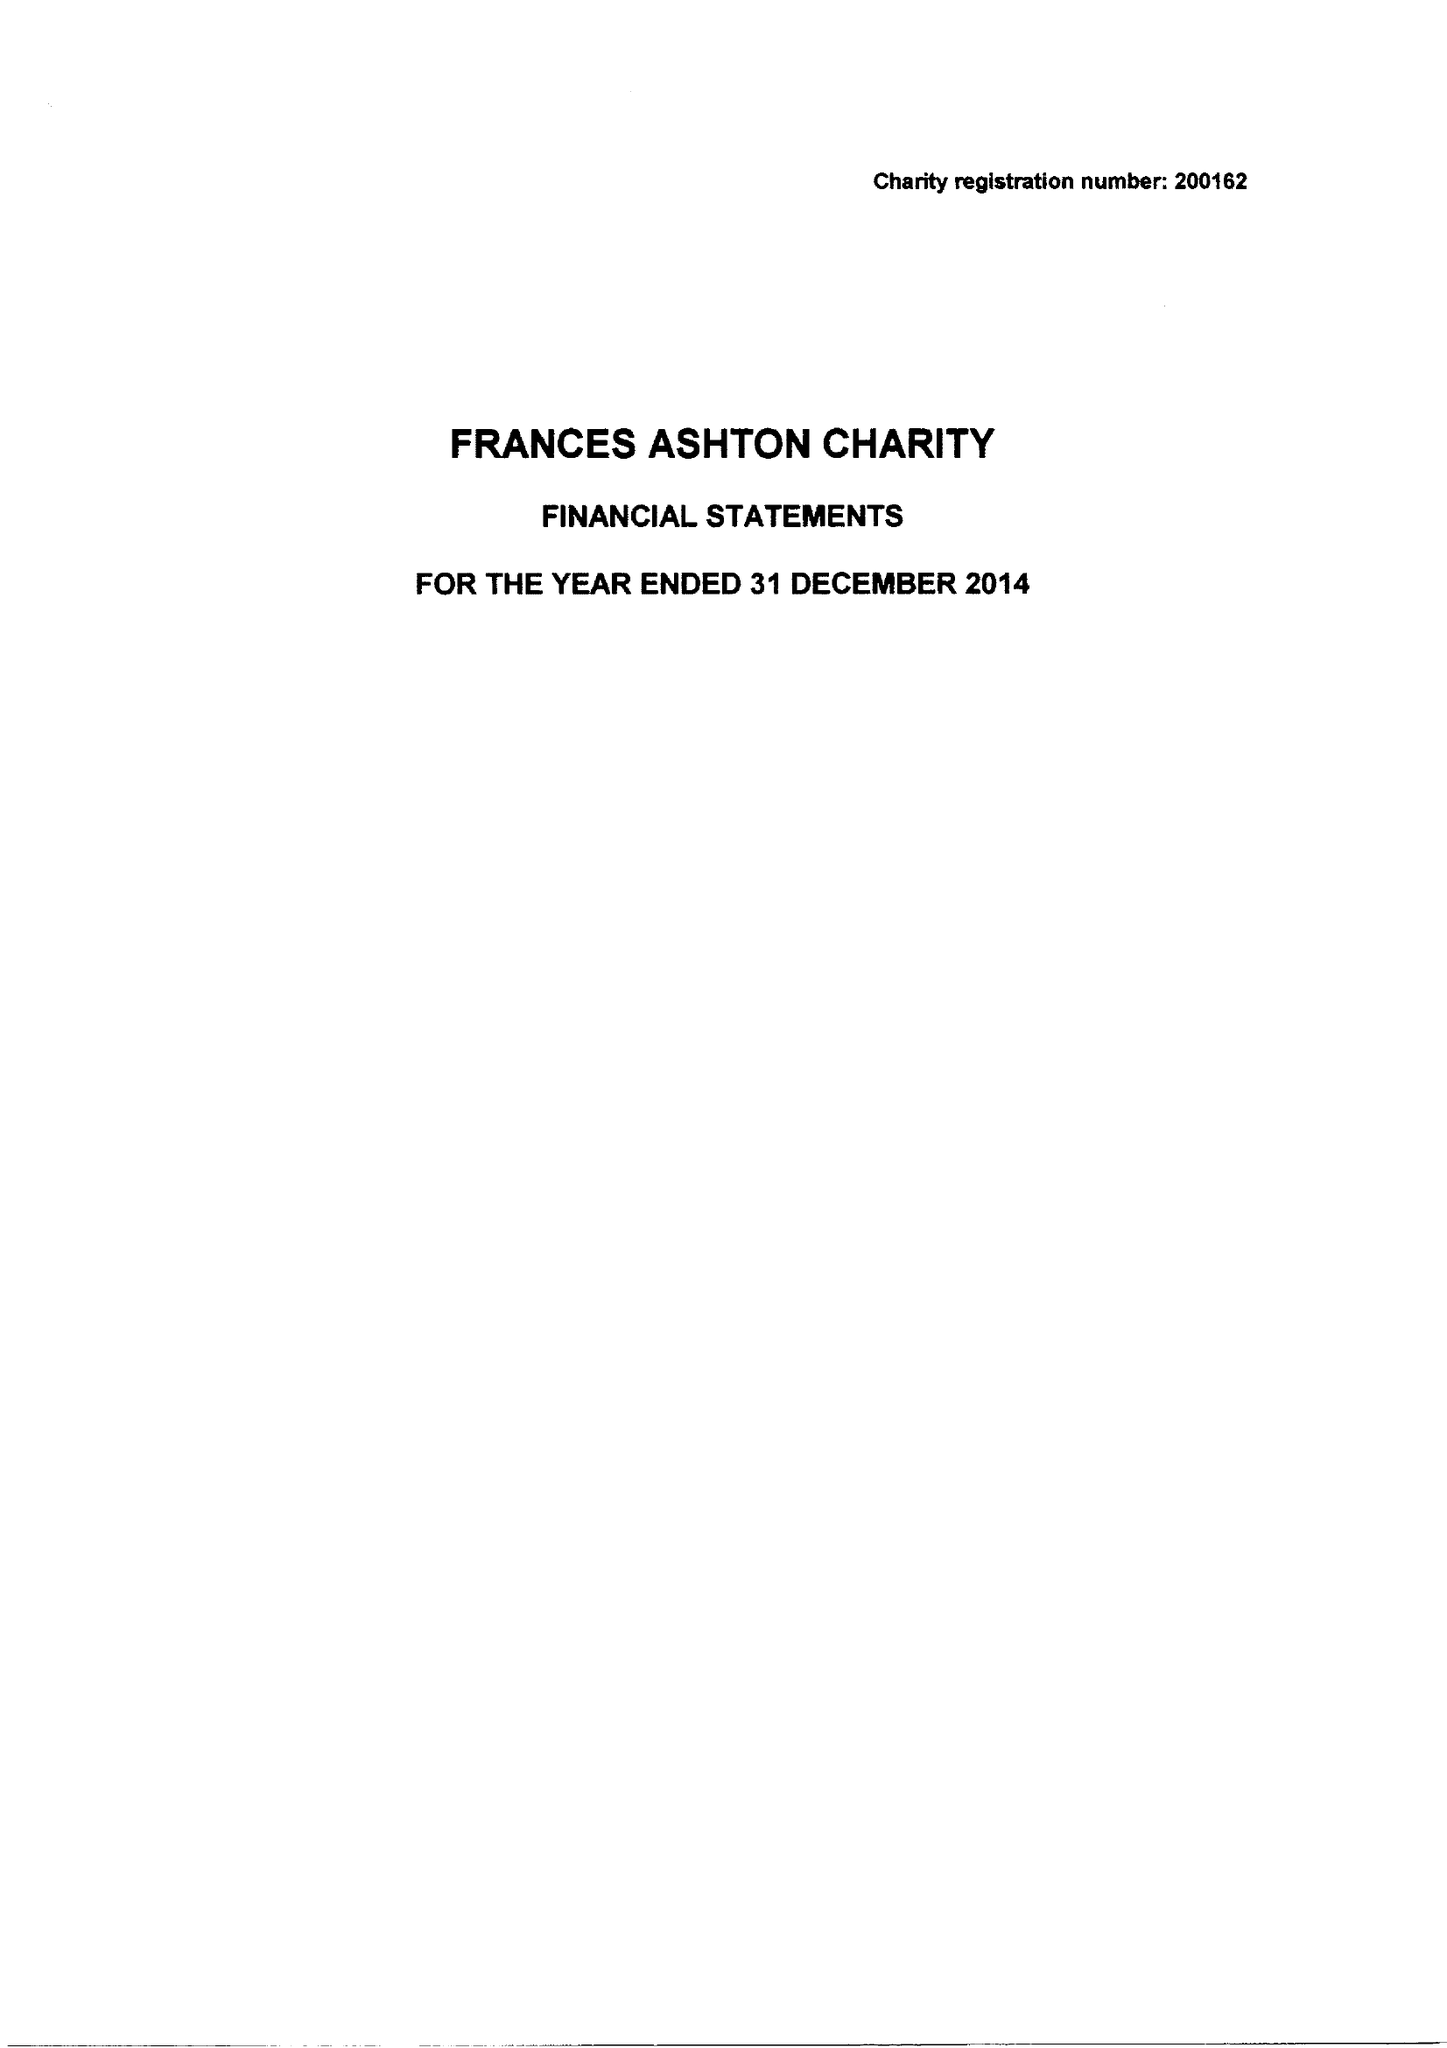What is the value for the spending_annually_in_british_pounds?
Answer the question using a single word or phrase. 61656.00 